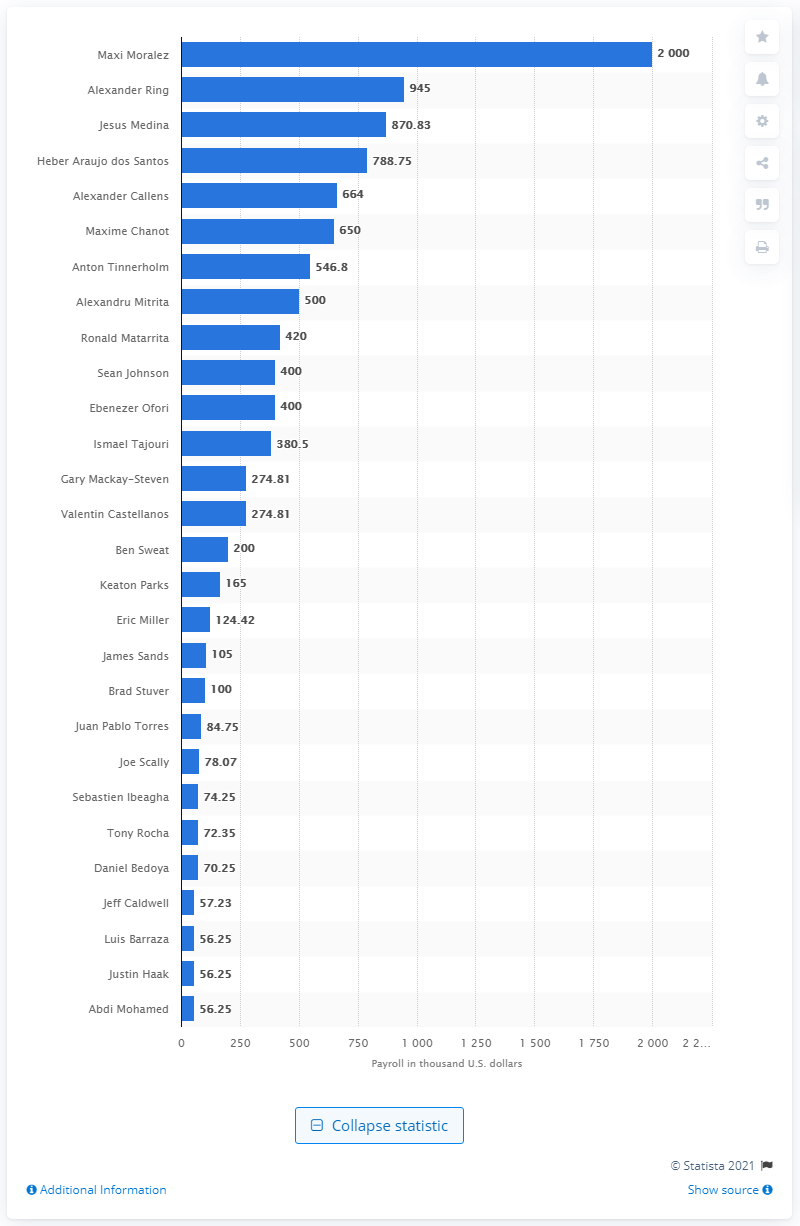Give some essential details in this illustration. Maxi Moralez received a salary of two million dollars. 